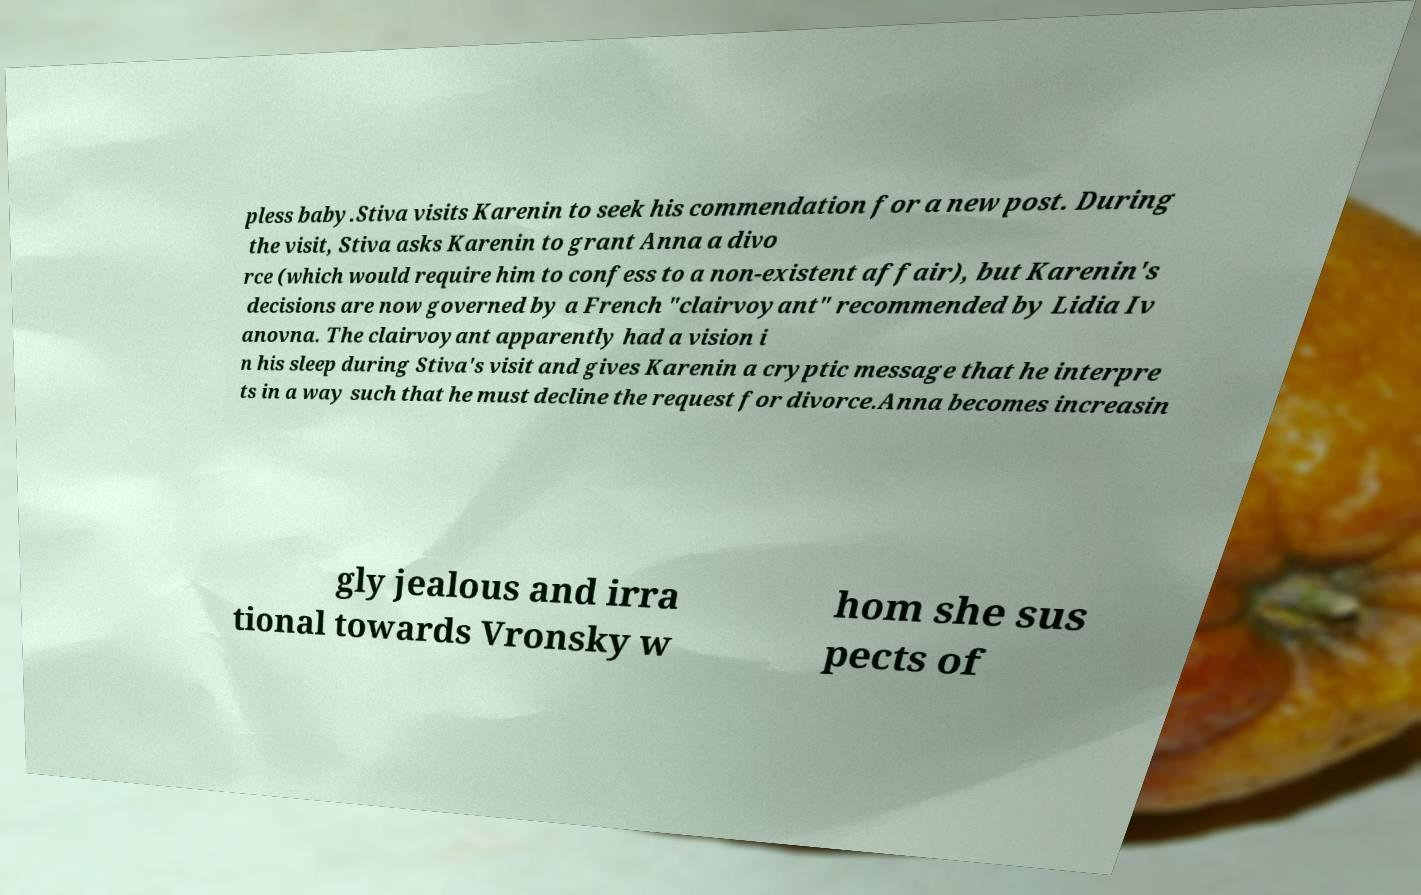Could you extract and type out the text from this image? pless baby.Stiva visits Karenin to seek his commendation for a new post. During the visit, Stiva asks Karenin to grant Anna a divo rce (which would require him to confess to a non-existent affair), but Karenin's decisions are now governed by a French "clairvoyant" recommended by Lidia Iv anovna. The clairvoyant apparently had a vision i n his sleep during Stiva's visit and gives Karenin a cryptic message that he interpre ts in a way such that he must decline the request for divorce.Anna becomes increasin gly jealous and irra tional towards Vronsky w hom she sus pects of 